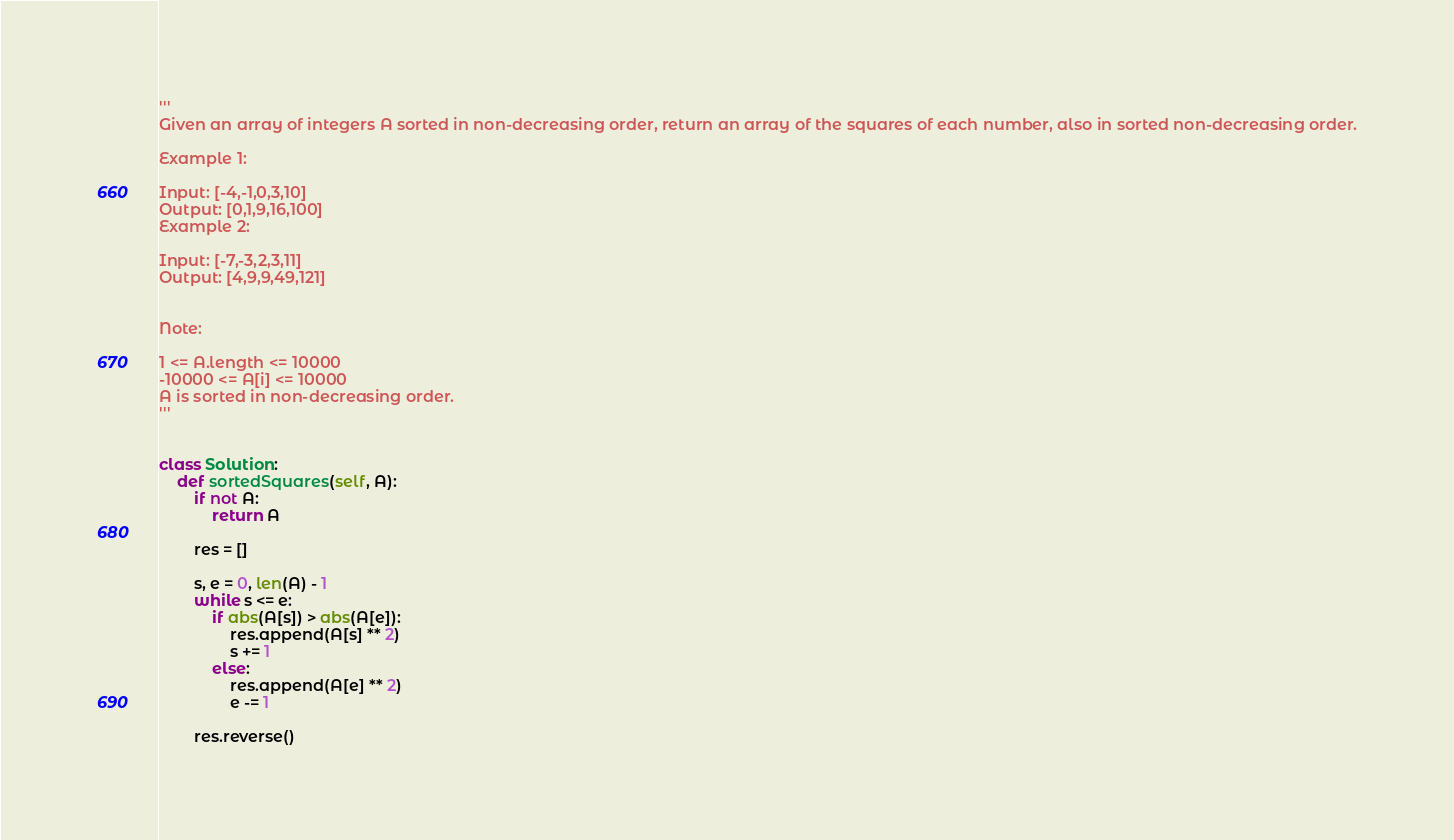Convert code to text. <code><loc_0><loc_0><loc_500><loc_500><_Python_>'''
Given an array of integers A sorted in non-decreasing order, return an array of the squares of each number, also in sorted non-decreasing order.

Example 1:

Input: [-4,-1,0,3,10]
Output: [0,1,9,16,100]
Example 2:

Input: [-7,-3,2,3,11]
Output: [4,9,9,49,121]
 

Note:

1 <= A.length <= 10000
-10000 <= A[i] <= 10000
A is sorted in non-decreasing order.
'''


class Solution:
    def sortedSquares(self, A):
        if not A:
            return A

        res = []

        s, e = 0, len(A) - 1
        while s <= e:
            if abs(A[s]) > abs(A[e]):
                res.append(A[s] ** 2)
                s += 1
            else:
                res.append(A[e] ** 2)
                e -= 1

        res.reverse()
</code> 